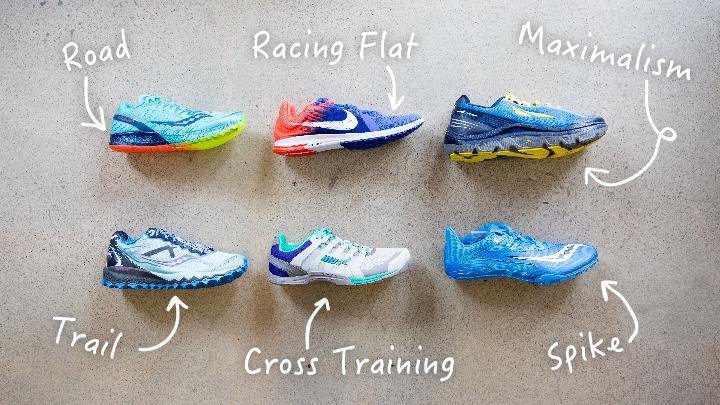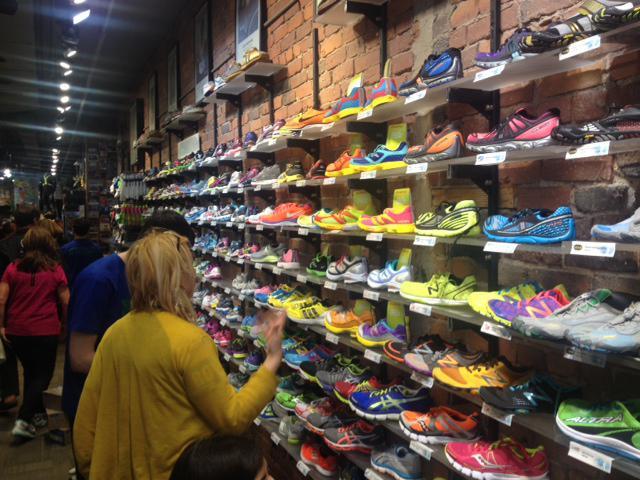The first image is the image on the left, the second image is the image on the right. Examine the images to the left and right. Is the description "One image shows different sneakers which are not displayed in rows on shelves." accurate? Answer yes or no. Yes. The first image is the image on the left, the second image is the image on the right. Considering the images on both sides, is "The shoes in one of the images are not sitting on the store racks." valid? Answer yes or no. Yes. 